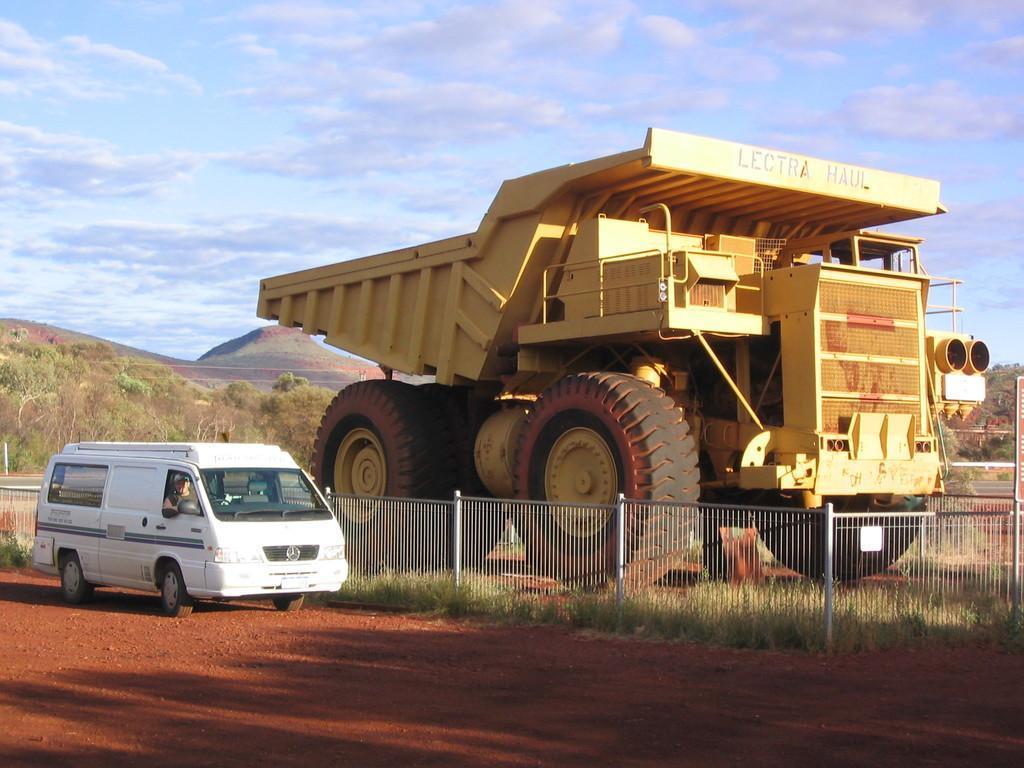How would you summarize this image in a sentence or two? There is a vehicle which is yellow in color in the right corner and there is a fence beside it and there is a white color vehicle in the left corner and there are trees in the background. 